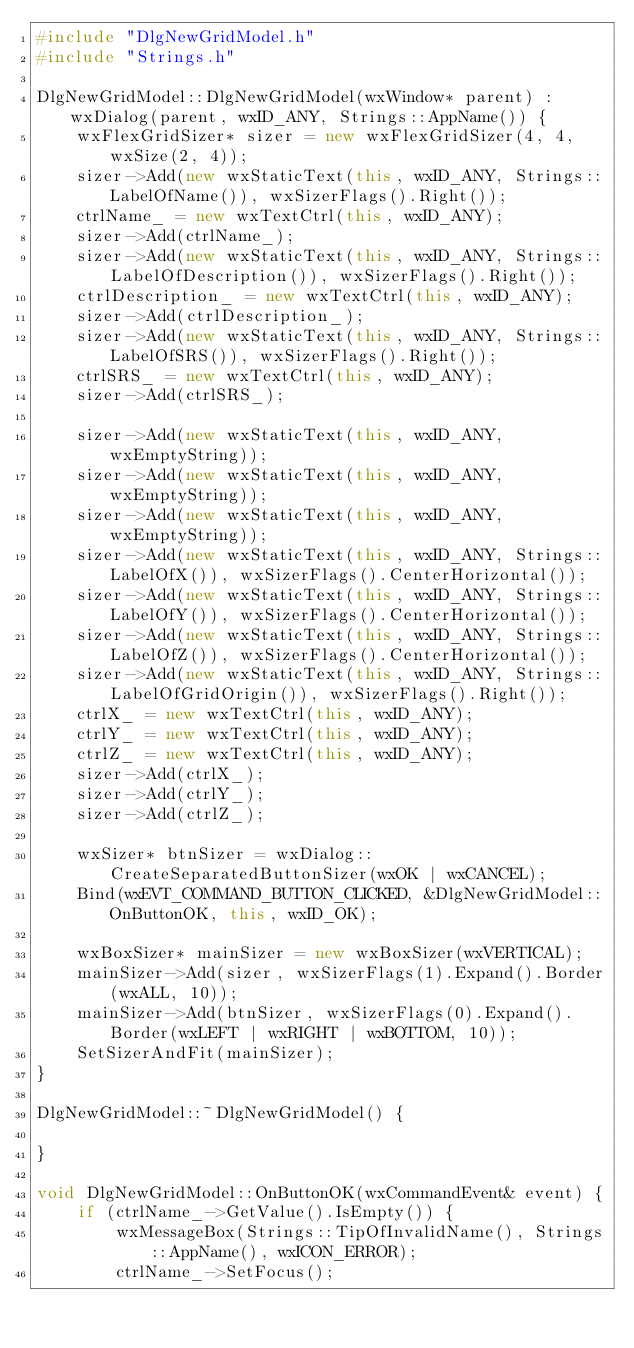Convert code to text. <code><loc_0><loc_0><loc_500><loc_500><_C++_>#include "DlgNewGridModel.h"
#include "Strings.h"

DlgNewGridModel::DlgNewGridModel(wxWindow* parent) : wxDialog(parent, wxID_ANY, Strings::AppName()) {
	wxFlexGridSizer* sizer = new wxFlexGridSizer(4, 4, wxSize(2, 4));
	sizer->Add(new wxStaticText(this, wxID_ANY, Strings::LabelOfName()), wxSizerFlags().Right());
	ctrlName_ = new wxTextCtrl(this, wxID_ANY);
	sizer->Add(ctrlName_);
	sizer->Add(new wxStaticText(this, wxID_ANY, Strings::LabelOfDescription()), wxSizerFlags().Right());
	ctrlDescription_ = new wxTextCtrl(this, wxID_ANY);
	sizer->Add(ctrlDescription_);
	sizer->Add(new wxStaticText(this, wxID_ANY, Strings::LabelOfSRS()), wxSizerFlags().Right());
	ctrlSRS_ = new wxTextCtrl(this, wxID_ANY);
	sizer->Add(ctrlSRS_);

	sizer->Add(new wxStaticText(this, wxID_ANY, wxEmptyString));
	sizer->Add(new wxStaticText(this, wxID_ANY, wxEmptyString));
	sizer->Add(new wxStaticText(this, wxID_ANY, wxEmptyString));
	sizer->Add(new wxStaticText(this, wxID_ANY, Strings::LabelOfX()), wxSizerFlags().CenterHorizontal());
	sizer->Add(new wxStaticText(this, wxID_ANY, Strings::LabelOfY()), wxSizerFlags().CenterHorizontal());
	sizer->Add(new wxStaticText(this, wxID_ANY, Strings::LabelOfZ()), wxSizerFlags().CenterHorizontal());
	sizer->Add(new wxStaticText(this, wxID_ANY, Strings::LabelOfGridOrigin()), wxSizerFlags().Right());
	ctrlX_ = new wxTextCtrl(this, wxID_ANY);
	ctrlY_ = new wxTextCtrl(this, wxID_ANY);
	ctrlZ_ = new wxTextCtrl(this, wxID_ANY);
	sizer->Add(ctrlX_);
	sizer->Add(ctrlY_);
	sizer->Add(ctrlZ_);

	wxSizer* btnSizer = wxDialog::CreateSeparatedButtonSizer(wxOK | wxCANCEL);
	Bind(wxEVT_COMMAND_BUTTON_CLICKED, &DlgNewGridModel::OnButtonOK, this, wxID_OK);

	wxBoxSizer* mainSizer = new wxBoxSizer(wxVERTICAL);
	mainSizer->Add(sizer, wxSizerFlags(1).Expand().Border(wxALL, 10));
	mainSizer->Add(btnSizer, wxSizerFlags(0).Expand().Border(wxLEFT | wxRIGHT | wxBOTTOM, 10));
	SetSizerAndFit(mainSizer);
}

DlgNewGridModel::~DlgNewGridModel() {

}

void DlgNewGridModel::OnButtonOK(wxCommandEvent& event) {
	if (ctrlName_->GetValue().IsEmpty()) {
		wxMessageBox(Strings::TipOfInvalidName(), Strings::AppName(), wxICON_ERROR);
		ctrlName_->SetFocus();</code> 